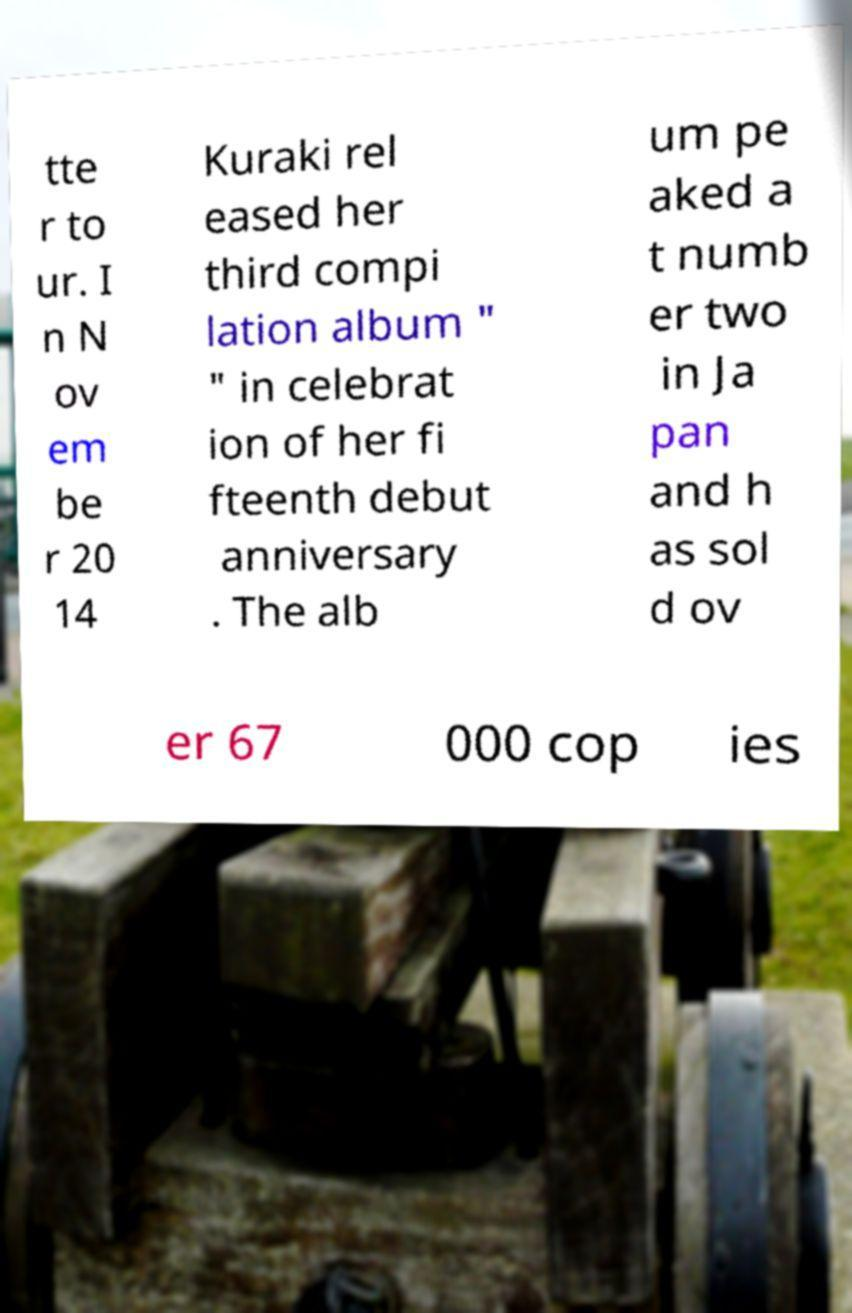Please identify and transcribe the text found in this image. tte r to ur. I n N ov em be r 20 14 Kuraki rel eased her third compi lation album " " in celebrat ion of her fi fteenth debut anniversary . The alb um pe aked a t numb er two in Ja pan and h as sol d ov er 67 000 cop ies 